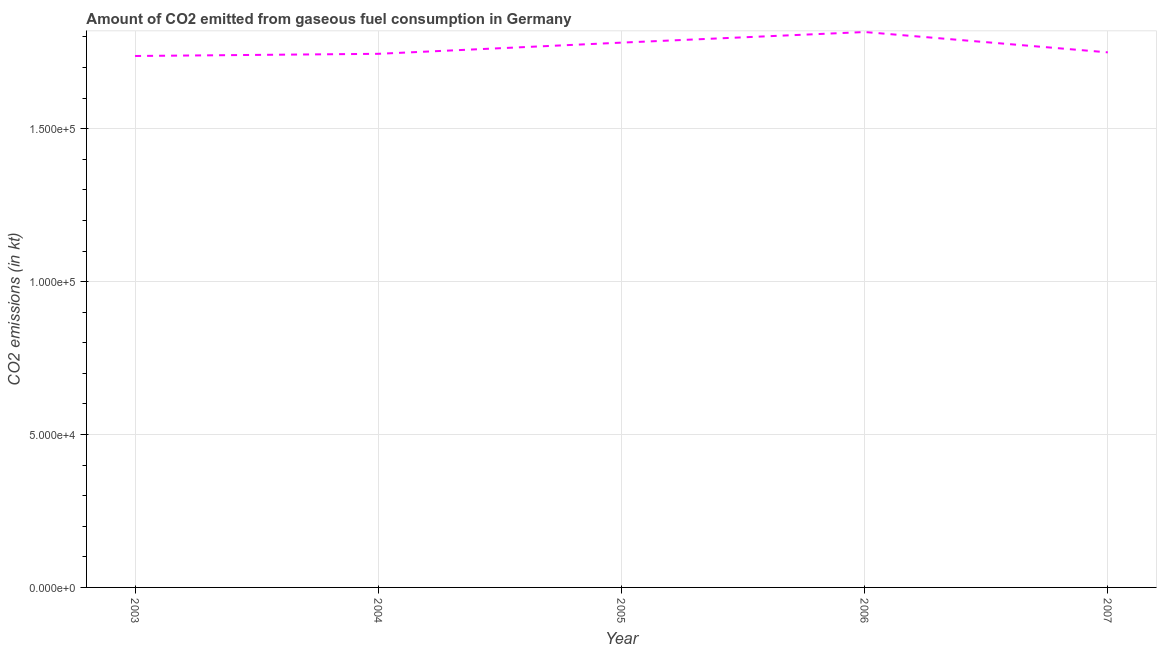What is the co2 emissions from gaseous fuel consumption in 2003?
Ensure brevity in your answer.  1.74e+05. Across all years, what is the maximum co2 emissions from gaseous fuel consumption?
Ensure brevity in your answer.  1.82e+05. Across all years, what is the minimum co2 emissions from gaseous fuel consumption?
Your answer should be compact. 1.74e+05. In which year was the co2 emissions from gaseous fuel consumption maximum?
Provide a succinct answer. 2006. In which year was the co2 emissions from gaseous fuel consumption minimum?
Ensure brevity in your answer.  2003. What is the sum of the co2 emissions from gaseous fuel consumption?
Your answer should be very brief. 8.83e+05. What is the difference between the co2 emissions from gaseous fuel consumption in 2004 and 2007?
Your answer should be very brief. -473.04. What is the average co2 emissions from gaseous fuel consumption per year?
Make the answer very short. 1.77e+05. What is the median co2 emissions from gaseous fuel consumption?
Make the answer very short. 1.75e+05. What is the ratio of the co2 emissions from gaseous fuel consumption in 2005 to that in 2006?
Offer a terse response. 0.98. Is the difference between the co2 emissions from gaseous fuel consumption in 2003 and 2005 greater than the difference between any two years?
Provide a succinct answer. No. What is the difference between the highest and the second highest co2 emissions from gaseous fuel consumption?
Ensure brevity in your answer.  3468.98. Is the sum of the co2 emissions from gaseous fuel consumption in 2003 and 2006 greater than the maximum co2 emissions from gaseous fuel consumption across all years?
Offer a terse response. Yes. What is the difference between the highest and the lowest co2 emissions from gaseous fuel consumption?
Provide a succinct answer. 7836.38. Does the co2 emissions from gaseous fuel consumption monotonically increase over the years?
Your answer should be very brief. No. How many years are there in the graph?
Make the answer very short. 5. What is the difference between two consecutive major ticks on the Y-axis?
Provide a short and direct response. 5.00e+04. What is the title of the graph?
Your response must be concise. Amount of CO2 emitted from gaseous fuel consumption in Germany. What is the label or title of the Y-axis?
Make the answer very short. CO2 emissions (in kt). What is the CO2 emissions (in kt) of 2003?
Offer a terse response. 1.74e+05. What is the CO2 emissions (in kt) of 2004?
Your response must be concise. 1.74e+05. What is the CO2 emissions (in kt) in 2005?
Your response must be concise. 1.78e+05. What is the CO2 emissions (in kt) of 2006?
Your answer should be compact. 1.82e+05. What is the CO2 emissions (in kt) in 2007?
Your response must be concise. 1.75e+05. What is the difference between the CO2 emissions (in kt) in 2003 and 2004?
Provide a succinct answer. -711.4. What is the difference between the CO2 emissions (in kt) in 2003 and 2005?
Offer a terse response. -4367.4. What is the difference between the CO2 emissions (in kt) in 2003 and 2006?
Provide a short and direct response. -7836.38. What is the difference between the CO2 emissions (in kt) in 2003 and 2007?
Offer a terse response. -1184.44. What is the difference between the CO2 emissions (in kt) in 2004 and 2005?
Offer a terse response. -3656. What is the difference between the CO2 emissions (in kt) in 2004 and 2006?
Ensure brevity in your answer.  -7124.98. What is the difference between the CO2 emissions (in kt) in 2004 and 2007?
Provide a short and direct response. -473.04. What is the difference between the CO2 emissions (in kt) in 2005 and 2006?
Offer a terse response. -3468.98. What is the difference between the CO2 emissions (in kt) in 2005 and 2007?
Provide a short and direct response. 3182.96. What is the difference between the CO2 emissions (in kt) in 2006 and 2007?
Ensure brevity in your answer.  6651.94. What is the ratio of the CO2 emissions (in kt) in 2003 to that in 2005?
Offer a very short reply. 0.97. What is the ratio of the CO2 emissions (in kt) in 2003 to that in 2006?
Your response must be concise. 0.96. What is the ratio of the CO2 emissions (in kt) in 2003 to that in 2007?
Provide a succinct answer. 0.99. What is the ratio of the CO2 emissions (in kt) in 2004 to that in 2005?
Your answer should be compact. 0.98. What is the ratio of the CO2 emissions (in kt) in 2004 to that in 2007?
Keep it short and to the point. 1. What is the ratio of the CO2 emissions (in kt) in 2005 to that in 2006?
Ensure brevity in your answer.  0.98. What is the ratio of the CO2 emissions (in kt) in 2005 to that in 2007?
Make the answer very short. 1.02. What is the ratio of the CO2 emissions (in kt) in 2006 to that in 2007?
Offer a terse response. 1.04. 